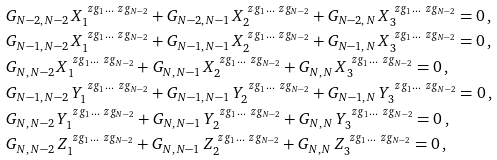<formula> <loc_0><loc_0><loc_500><loc_500>& G _ { N - 2 , \, N - 2 } \, X _ { 1 } ^ { \ z g _ { 1 } \dots \ z g _ { N - 2 } } + G _ { N - 2 , \, N - 1 } \, X _ { 2 } ^ { \ z g _ { 1 } \dots \ z g _ { N - 2 } } + G _ { N - 2 , \, N } \, X _ { 3 } ^ { \ z g _ { 1 } \dots \ z g _ { N - 2 } } = 0 \, , \\ & G _ { N - 1 , \, N - 2 } \, X _ { 1 } ^ { \ z g _ { 1 } \dots \ z g _ { N - 2 } } + G _ { N - 1 , \, N - 1 } \, X _ { 2 } ^ { \ z g _ { 1 } \dots \ z g _ { N - 2 } } + G _ { N - 1 , \, N } \, X _ { 3 } ^ { \ z g _ { 1 } \dots \ z g _ { N - 2 } } = 0 \, , \\ & G _ { N , \, N - 2 } \, X _ { 1 } ^ { \ z g _ { 1 } \dots \ z g _ { N - 2 } } + G _ { N , \, N - 1 } \, X _ { 2 } ^ { \ z g _ { 1 } \dots \ z g _ { N - 2 } } + G _ { N , \, N } \, X _ { 3 } ^ { \ z g _ { 1 } \dots \ z g _ { N - 2 } } = 0 \, , \\ & G _ { N - 1 , \, N - 2 } \, Y _ { 1 } ^ { \ z g _ { 1 } \dots \ z g _ { N - 2 } } + G _ { N - 1 , \, N - 1 } \, Y _ { 2 } ^ { \ z g _ { 1 } \dots \ z g _ { N - 2 } } + G _ { N - 1 , \, N } \, Y _ { 3 } ^ { \ z g _ { 1 } \dots \ z g _ { N - 2 } } = 0 \, , \\ & G _ { N , \, N - 2 } \, Y _ { 1 } ^ { \ z g _ { 1 } \dots \ z g _ { N - 2 } } + G _ { N , \, N - 1 } \, Y _ { 2 } ^ { \ z g _ { 1 } \dots \ z g _ { N - 2 } } + G _ { N , \, N } \, Y _ { 3 } ^ { \ z g _ { 1 } \dots \ z g _ { N - 2 } } = 0 \, , \\ & G _ { N , \, N - 2 } \, Z _ { 1 } ^ { \ z g _ { 1 } \dots \ z g _ { N - 2 } } + G _ { N , \, N - 1 } \, Z _ { 2 } ^ { \ z g _ { 1 } \dots \ z g _ { N - 2 } } + G _ { N , \, N } \, Z _ { 3 } ^ { \ z g _ { 1 } \dots \ z g _ { N - 2 } } = 0 \, ,</formula> 